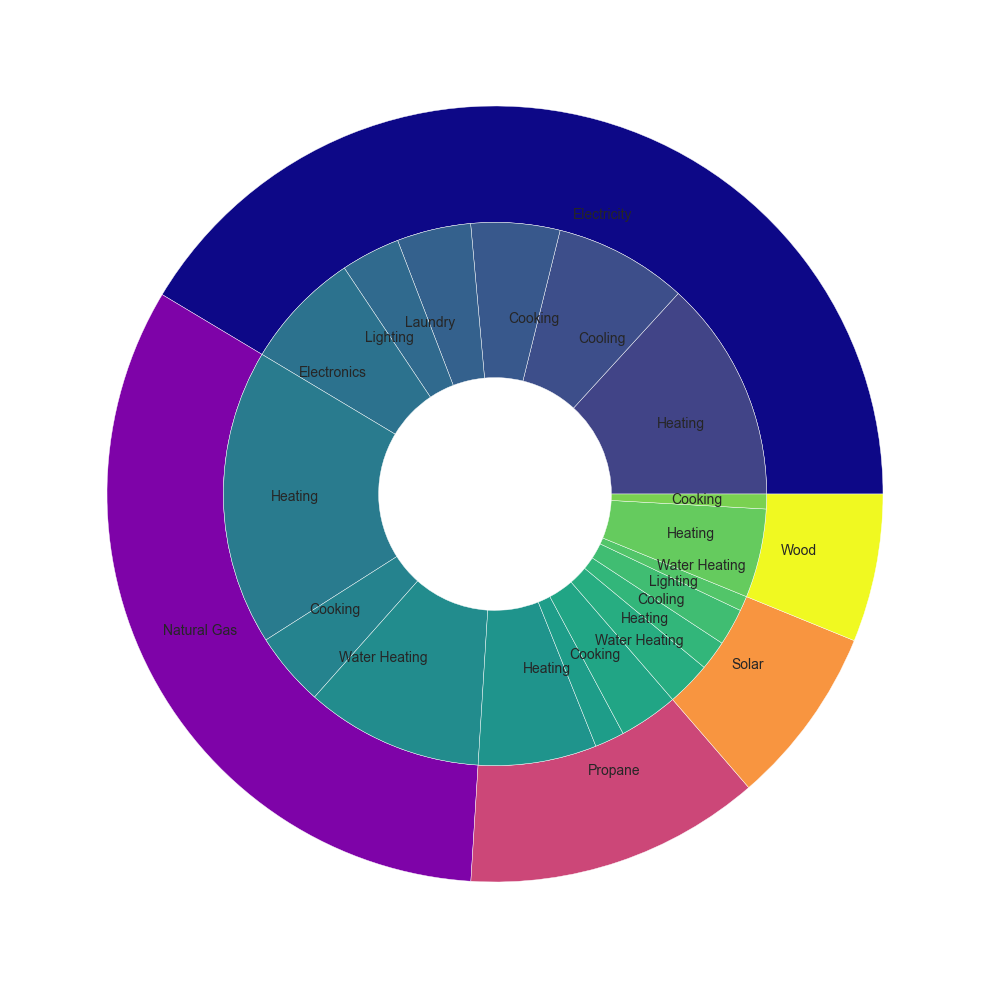Which energy source has the highest total energy consumption? The outer ring of the pie chart represents the total energy consumption for each energy source. By comparing the sizes of the outer wedges, it's clear that Natural Gas has the largest wedge, indicating the highest total energy consumption.
Answer: Natural Gas Which appliance category uses the most electricity? The inner ring represents different appliance categories, and by identifying the sections labeled under "Electricity," "Heating" has the largest slice among them. Therefore, heating uses the most electricity.
Answer: Heating Compare the total energy consumption of heating using electricity versus heating using natural gas. Which is higher, and by how much? The slice sizes for "Heating" under Electricity and Natural Gas can be compared directly. Electricity used for heating is 1500 kWh, while Natural Gas used for heating is 2000 kWh. Natural Gas is higher by 500 kWh.
Answer: Natural Gas by 500 kWh What is the combined energy consumption of heating using solar and wood? By adding up the consumption values for "Heating" under Solar (300 kWh) and Wood (600 kWh), the combined energy consumption is 900 kWh.
Answer: 900 kWh Which appliance category has the smallest energy consumption using propane, and what is its value? The appliance categories under Propane can be identified, and the smallest wedge among them is "Cooking," with an energy consumption of 200 kWh.
Answer: Cooking, 200 kWh What color represents the lighting category in the inner ring? The sections labeled "Lighting" in the inner ring need to be identified. These sections are colored, and using natural language, they are primarily shades found from the chosen colormap in the pie chart, which is typically a shade from the color gradient.
Answer: Typically green (or a shade related to the colormap) What is the difference in energy consumption between water heating with natural gas and electricity? Identify the slices for "Water Heating" under Natural Gas and Electricity. Natural Gas for water heating is 1200 kWh, and Electricity has no direct water heating listed. Therefore, the difference is between 1200 kWh and 0 kWh.
Answer: 1200 kWh How many energy sources are represented in the energy consumption data? The outer ring shows the different energy sources. By counting the distinct sections, there are five energy sources: Electricity, Natural Gas, Propane, Solar, and Wood.
Answer: Five What is the second highest energy consuming appliance category across all energy sources? Identify the largest and second largest slices in the inner ring. The largest is "Heating" for Natural Gas. The second largest combined category is "Water Heating" under Natural Gas (1200 kWh).
Answer: Water Heating Compare energy consumption in cooking between electricity and solar. Which consumes more and by how much? Locate the slices for "Cooking" under Electricity (600 kWh) and Solar (none directly mentioned, thus 0 kWh). Electricity consumes more by 600 kWh.
Answer: Electricity by 600 kWh 